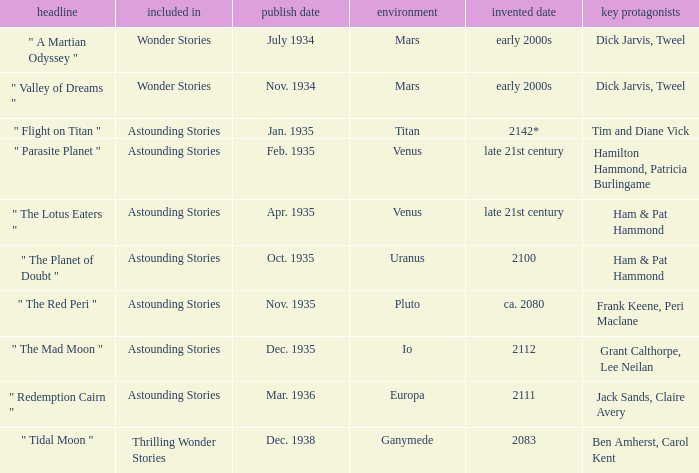What was the title of the piece published in july 1934 set on mars? Wonder Stories. 